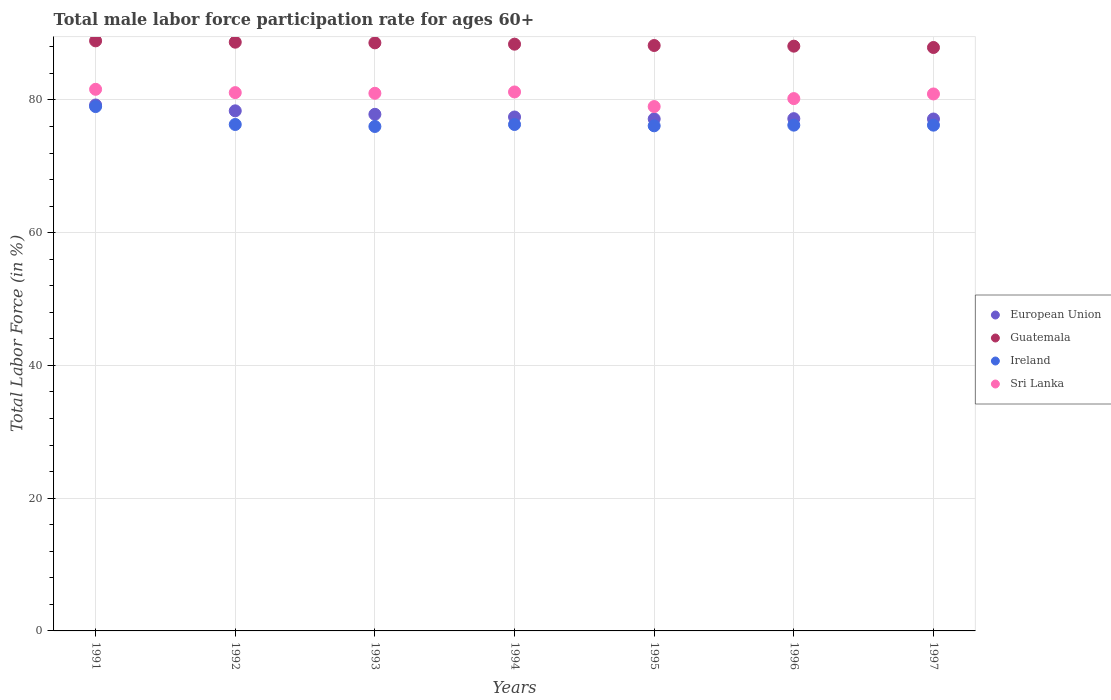How many different coloured dotlines are there?
Provide a short and direct response. 4. Is the number of dotlines equal to the number of legend labels?
Offer a terse response. Yes. What is the male labor force participation rate in European Union in 1997?
Provide a succinct answer. 77.12. Across all years, what is the maximum male labor force participation rate in Sri Lanka?
Provide a succinct answer. 81.6. Across all years, what is the minimum male labor force participation rate in European Union?
Make the answer very short. 77.12. In which year was the male labor force participation rate in Guatemala maximum?
Your answer should be very brief. 1991. What is the total male labor force participation rate in Guatemala in the graph?
Make the answer very short. 618.8. What is the difference between the male labor force participation rate in Sri Lanka in 1993 and that in 1996?
Provide a succinct answer. 0.8. What is the difference between the male labor force participation rate in Guatemala in 1994 and the male labor force participation rate in Sri Lanka in 1996?
Give a very brief answer. 8.2. What is the average male labor force participation rate in Ireland per year?
Provide a succinct answer. 76.59. In the year 1996, what is the difference between the male labor force participation rate in European Union and male labor force participation rate in Guatemala?
Your answer should be very brief. -10.92. What is the ratio of the male labor force participation rate in Guatemala in 1994 to that in 1996?
Your response must be concise. 1. Is the male labor force participation rate in Ireland in 1994 less than that in 1996?
Give a very brief answer. No. What is the difference between the highest and the second highest male labor force participation rate in Guatemala?
Offer a very short reply. 0.2. What is the difference between the highest and the lowest male labor force participation rate in Sri Lanka?
Give a very brief answer. 2.6. In how many years, is the male labor force participation rate in European Union greater than the average male labor force participation rate in European Union taken over all years?
Provide a succinct answer. 3. Is it the case that in every year, the sum of the male labor force participation rate in Sri Lanka and male labor force participation rate in Guatemala  is greater than the sum of male labor force participation rate in European Union and male labor force participation rate in Ireland?
Provide a short and direct response. No. Is it the case that in every year, the sum of the male labor force participation rate in European Union and male labor force participation rate in Sri Lanka  is greater than the male labor force participation rate in Guatemala?
Ensure brevity in your answer.  Yes. Is the male labor force participation rate in Ireland strictly less than the male labor force participation rate in Sri Lanka over the years?
Provide a succinct answer. Yes. How many dotlines are there?
Provide a short and direct response. 4. What is the difference between two consecutive major ticks on the Y-axis?
Provide a succinct answer. 20. Does the graph contain any zero values?
Make the answer very short. No. How are the legend labels stacked?
Offer a very short reply. Vertical. What is the title of the graph?
Your answer should be compact. Total male labor force participation rate for ages 60+. What is the label or title of the Y-axis?
Keep it short and to the point. Total Labor Force (in %). What is the Total Labor Force (in %) of European Union in 1991?
Your response must be concise. 79.24. What is the Total Labor Force (in %) of Guatemala in 1991?
Give a very brief answer. 88.9. What is the Total Labor Force (in %) in Ireland in 1991?
Ensure brevity in your answer.  79. What is the Total Labor Force (in %) in Sri Lanka in 1991?
Give a very brief answer. 81.6. What is the Total Labor Force (in %) of European Union in 1992?
Offer a very short reply. 78.36. What is the Total Labor Force (in %) in Guatemala in 1992?
Offer a terse response. 88.7. What is the Total Labor Force (in %) in Ireland in 1992?
Offer a very short reply. 76.3. What is the Total Labor Force (in %) in Sri Lanka in 1992?
Ensure brevity in your answer.  81.1. What is the Total Labor Force (in %) in European Union in 1993?
Provide a short and direct response. 77.83. What is the Total Labor Force (in %) of Guatemala in 1993?
Offer a very short reply. 88.6. What is the Total Labor Force (in %) in Sri Lanka in 1993?
Offer a very short reply. 81. What is the Total Labor Force (in %) in European Union in 1994?
Ensure brevity in your answer.  77.43. What is the Total Labor Force (in %) in Guatemala in 1994?
Your answer should be compact. 88.4. What is the Total Labor Force (in %) of Ireland in 1994?
Offer a terse response. 76.3. What is the Total Labor Force (in %) in Sri Lanka in 1994?
Ensure brevity in your answer.  81.2. What is the Total Labor Force (in %) of European Union in 1995?
Make the answer very short. 77.14. What is the Total Labor Force (in %) of Guatemala in 1995?
Your response must be concise. 88.2. What is the Total Labor Force (in %) in Ireland in 1995?
Ensure brevity in your answer.  76.1. What is the Total Labor Force (in %) of Sri Lanka in 1995?
Offer a terse response. 79. What is the Total Labor Force (in %) of European Union in 1996?
Keep it short and to the point. 77.18. What is the Total Labor Force (in %) of Guatemala in 1996?
Your response must be concise. 88.1. What is the Total Labor Force (in %) in Ireland in 1996?
Keep it short and to the point. 76.2. What is the Total Labor Force (in %) of Sri Lanka in 1996?
Keep it short and to the point. 80.2. What is the Total Labor Force (in %) in European Union in 1997?
Keep it short and to the point. 77.12. What is the Total Labor Force (in %) in Guatemala in 1997?
Ensure brevity in your answer.  87.9. What is the Total Labor Force (in %) in Ireland in 1997?
Keep it short and to the point. 76.2. What is the Total Labor Force (in %) in Sri Lanka in 1997?
Keep it short and to the point. 80.9. Across all years, what is the maximum Total Labor Force (in %) in European Union?
Provide a short and direct response. 79.24. Across all years, what is the maximum Total Labor Force (in %) in Guatemala?
Offer a terse response. 88.9. Across all years, what is the maximum Total Labor Force (in %) in Ireland?
Provide a succinct answer. 79. Across all years, what is the maximum Total Labor Force (in %) in Sri Lanka?
Offer a very short reply. 81.6. Across all years, what is the minimum Total Labor Force (in %) of European Union?
Offer a terse response. 77.12. Across all years, what is the minimum Total Labor Force (in %) of Guatemala?
Give a very brief answer. 87.9. Across all years, what is the minimum Total Labor Force (in %) of Ireland?
Your response must be concise. 76. Across all years, what is the minimum Total Labor Force (in %) in Sri Lanka?
Keep it short and to the point. 79. What is the total Total Labor Force (in %) in European Union in the graph?
Provide a succinct answer. 544.29. What is the total Total Labor Force (in %) of Guatemala in the graph?
Make the answer very short. 618.8. What is the total Total Labor Force (in %) in Ireland in the graph?
Your response must be concise. 536.1. What is the total Total Labor Force (in %) in Sri Lanka in the graph?
Give a very brief answer. 565. What is the difference between the Total Labor Force (in %) in European Union in 1991 and that in 1992?
Give a very brief answer. 0.88. What is the difference between the Total Labor Force (in %) in Guatemala in 1991 and that in 1992?
Make the answer very short. 0.2. What is the difference between the Total Labor Force (in %) of Sri Lanka in 1991 and that in 1992?
Provide a short and direct response. 0.5. What is the difference between the Total Labor Force (in %) in European Union in 1991 and that in 1993?
Offer a terse response. 1.41. What is the difference between the Total Labor Force (in %) of Guatemala in 1991 and that in 1993?
Your answer should be compact. 0.3. What is the difference between the Total Labor Force (in %) in Ireland in 1991 and that in 1993?
Keep it short and to the point. 3. What is the difference between the Total Labor Force (in %) of European Union in 1991 and that in 1994?
Offer a terse response. 1.81. What is the difference between the Total Labor Force (in %) of Guatemala in 1991 and that in 1994?
Your response must be concise. 0.5. What is the difference between the Total Labor Force (in %) of Sri Lanka in 1991 and that in 1994?
Make the answer very short. 0.4. What is the difference between the Total Labor Force (in %) in European Union in 1991 and that in 1995?
Your answer should be very brief. 2.1. What is the difference between the Total Labor Force (in %) of Guatemala in 1991 and that in 1995?
Ensure brevity in your answer.  0.7. What is the difference between the Total Labor Force (in %) in European Union in 1991 and that in 1996?
Give a very brief answer. 2.06. What is the difference between the Total Labor Force (in %) of Ireland in 1991 and that in 1996?
Provide a short and direct response. 2.8. What is the difference between the Total Labor Force (in %) in Sri Lanka in 1991 and that in 1996?
Offer a terse response. 1.4. What is the difference between the Total Labor Force (in %) of European Union in 1991 and that in 1997?
Give a very brief answer. 2.11. What is the difference between the Total Labor Force (in %) in Ireland in 1991 and that in 1997?
Keep it short and to the point. 2.8. What is the difference between the Total Labor Force (in %) in Sri Lanka in 1991 and that in 1997?
Offer a very short reply. 0.7. What is the difference between the Total Labor Force (in %) in European Union in 1992 and that in 1993?
Give a very brief answer. 0.53. What is the difference between the Total Labor Force (in %) in European Union in 1992 and that in 1994?
Your response must be concise. 0.93. What is the difference between the Total Labor Force (in %) of Guatemala in 1992 and that in 1994?
Provide a short and direct response. 0.3. What is the difference between the Total Labor Force (in %) of Ireland in 1992 and that in 1994?
Give a very brief answer. 0. What is the difference between the Total Labor Force (in %) in European Union in 1992 and that in 1995?
Provide a succinct answer. 1.22. What is the difference between the Total Labor Force (in %) of Sri Lanka in 1992 and that in 1995?
Give a very brief answer. 2.1. What is the difference between the Total Labor Force (in %) of European Union in 1992 and that in 1996?
Provide a succinct answer. 1.18. What is the difference between the Total Labor Force (in %) in European Union in 1992 and that in 1997?
Your answer should be compact. 1.23. What is the difference between the Total Labor Force (in %) in European Union in 1993 and that in 1994?
Make the answer very short. 0.4. What is the difference between the Total Labor Force (in %) in Guatemala in 1993 and that in 1994?
Keep it short and to the point. 0.2. What is the difference between the Total Labor Force (in %) of Ireland in 1993 and that in 1994?
Your response must be concise. -0.3. What is the difference between the Total Labor Force (in %) in Sri Lanka in 1993 and that in 1994?
Keep it short and to the point. -0.2. What is the difference between the Total Labor Force (in %) of European Union in 1993 and that in 1995?
Your answer should be compact. 0.69. What is the difference between the Total Labor Force (in %) of Guatemala in 1993 and that in 1995?
Your answer should be compact. 0.4. What is the difference between the Total Labor Force (in %) in Sri Lanka in 1993 and that in 1995?
Provide a succinct answer. 2. What is the difference between the Total Labor Force (in %) in European Union in 1993 and that in 1996?
Give a very brief answer. 0.66. What is the difference between the Total Labor Force (in %) in Sri Lanka in 1993 and that in 1996?
Offer a terse response. 0.8. What is the difference between the Total Labor Force (in %) of European Union in 1993 and that in 1997?
Offer a terse response. 0.71. What is the difference between the Total Labor Force (in %) of European Union in 1994 and that in 1995?
Keep it short and to the point. 0.29. What is the difference between the Total Labor Force (in %) in Guatemala in 1994 and that in 1995?
Your answer should be very brief. 0.2. What is the difference between the Total Labor Force (in %) of Ireland in 1994 and that in 1995?
Your response must be concise. 0.2. What is the difference between the Total Labor Force (in %) of Sri Lanka in 1994 and that in 1995?
Offer a terse response. 2.2. What is the difference between the Total Labor Force (in %) of European Union in 1994 and that in 1996?
Your answer should be compact. 0.25. What is the difference between the Total Labor Force (in %) in Guatemala in 1994 and that in 1996?
Ensure brevity in your answer.  0.3. What is the difference between the Total Labor Force (in %) of Ireland in 1994 and that in 1996?
Make the answer very short. 0.1. What is the difference between the Total Labor Force (in %) in Sri Lanka in 1994 and that in 1996?
Your answer should be compact. 1. What is the difference between the Total Labor Force (in %) in European Union in 1994 and that in 1997?
Provide a short and direct response. 0.3. What is the difference between the Total Labor Force (in %) of Guatemala in 1994 and that in 1997?
Provide a short and direct response. 0.5. What is the difference between the Total Labor Force (in %) in European Union in 1995 and that in 1996?
Give a very brief answer. -0.04. What is the difference between the Total Labor Force (in %) of Guatemala in 1995 and that in 1996?
Keep it short and to the point. 0.1. What is the difference between the Total Labor Force (in %) of Ireland in 1995 and that in 1996?
Offer a terse response. -0.1. What is the difference between the Total Labor Force (in %) in European Union in 1995 and that in 1997?
Your answer should be compact. 0.01. What is the difference between the Total Labor Force (in %) of Guatemala in 1995 and that in 1997?
Your answer should be compact. 0.3. What is the difference between the Total Labor Force (in %) of Ireland in 1995 and that in 1997?
Your answer should be very brief. -0.1. What is the difference between the Total Labor Force (in %) in Sri Lanka in 1995 and that in 1997?
Ensure brevity in your answer.  -1.9. What is the difference between the Total Labor Force (in %) of European Union in 1996 and that in 1997?
Provide a succinct answer. 0.05. What is the difference between the Total Labor Force (in %) in European Union in 1991 and the Total Labor Force (in %) in Guatemala in 1992?
Make the answer very short. -9.46. What is the difference between the Total Labor Force (in %) of European Union in 1991 and the Total Labor Force (in %) of Ireland in 1992?
Ensure brevity in your answer.  2.94. What is the difference between the Total Labor Force (in %) in European Union in 1991 and the Total Labor Force (in %) in Sri Lanka in 1992?
Ensure brevity in your answer.  -1.86. What is the difference between the Total Labor Force (in %) of Ireland in 1991 and the Total Labor Force (in %) of Sri Lanka in 1992?
Offer a very short reply. -2.1. What is the difference between the Total Labor Force (in %) of European Union in 1991 and the Total Labor Force (in %) of Guatemala in 1993?
Offer a very short reply. -9.36. What is the difference between the Total Labor Force (in %) in European Union in 1991 and the Total Labor Force (in %) in Ireland in 1993?
Provide a succinct answer. 3.24. What is the difference between the Total Labor Force (in %) in European Union in 1991 and the Total Labor Force (in %) in Sri Lanka in 1993?
Provide a short and direct response. -1.76. What is the difference between the Total Labor Force (in %) of Ireland in 1991 and the Total Labor Force (in %) of Sri Lanka in 1993?
Offer a terse response. -2. What is the difference between the Total Labor Force (in %) in European Union in 1991 and the Total Labor Force (in %) in Guatemala in 1994?
Your response must be concise. -9.16. What is the difference between the Total Labor Force (in %) in European Union in 1991 and the Total Labor Force (in %) in Ireland in 1994?
Offer a very short reply. 2.94. What is the difference between the Total Labor Force (in %) of European Union in 1991 and the Total Labor Force (in %) of Sri Lanka in 1994?
Offer a terse response. -1.96. What is the difference between the Total Labor Force (in %) in Guatemala in 1991 and the Total Labor Force (in %) in Ireland in 1994?
Offer a terse response. 12.6. What is the difference between the Total Labor Force (in %) of Guatemala in 1991 and the Total Labor Force (in %) of Sri Lanka in 1994?
Your answer should be very brief. 7.7. What is the difference between the Total Labor Force (in %) in Ireland in 1991 and the Total Labor Force (in %) in Sri Lanka in 1994?
Give a very brief answer. -2.2. What is the difference between the Total Labor Force (in %) of European Union in 1991 and the Total Labor Force (in %) of Guatemala in 1995?
Your response must be concise. -8.96. What is the difference between the Total Labor Force (in %) in European Union in 1991 and the Total Labor Force (in %) in Ireland in 1995?
Offer a very short reply. 3.14. What is the difference between the Total Labor Force (in %) in European Union in 1991 and the Total Labor Force (in %) in Sri Lanka in 1995?
Ensure brevity in your answer.  0.24. What is the difference between the Total Labor Force (in %) in Guatemala in 1991 and the Total Labor Force (in %) in Sri Lanka in 1995?
Give a very brief answer. 9.9. What is the difference between the Total Labor Force (in %) in Ireland in 1991 and the Total Labor Force (in %) in Sri Lanka in 1995?
Offer a very short reply. 0. What is the difference between the Total Labor Force (in %) in European Union in 1991 and the Total Labor Force (in %) in Guatemala in 1996?
Ensure brevity in your answer.  -8.86. What is the difference between the Total Labor Force (in %) in European Union in 1991 and the Total Labor Force (in %) in Ireland in 1996?
Provide a short and direct response. 3.04. What is the difference between the Total Labor Force (in %) of European Union in 1991 and the Total Labor Force (in %) of Sri Lanka in 1996?
Offer a very short reply. -0.96. What is the difference between the Total Labor Force (in %) of Guatemala in 1991 and the Total Labor Force (in %) of Sri Lanka in 1996?
Your response must be concise. 8.7. What is the difference between the Total Labor Force (in %) in European Union in 1991 and the Total Labor Force (in %) in Guatemala in 1997?
Ensure brevity in your answer.  -8.66. What is the difference between the Total Labor Force (in %) of European Union in 1991 and the Total Labor Force (in %) of Ireland in 1997?
Your answer should be very brief. 3.04. What is the difference between the Total Labor Force (in %) in European Union in 1991 and the Total Labor Force (in %) in Sri Lanka in 1997?
Your answer should be very brief. -1.66. What is the difference between the Total Labor Force (in %) in European Union in 1992 and the Total Labor Force (in %) in Guatemala in 1993?
Offer a terse response. -10.24. What is the difference between the Total Labor Force (in %) in European Union in 1992 and the Total Labor Force (in %) in Ireland in 1993?
Provide a short and direct response. 2.36. What is the difference between the Total Labor Force (in %) in European Union in 1992 and the Total Labor Force (in %) in Sri Lanka in 1993?
Offer a terse response. -2.64. What is the difference between the Total Labor Force (in %) of Guatemala in 1992 and the Total Labor Force (in %) of Sri Lanka in 1993?
Offer a very short reply. 7.7. What is the difference between the Total Labor Force (in %) in Ireland in 1992 and the Total Labor Force (in %) in Sri Lanka in 1993?
Make the answer very short. -4.7. What is the difference between the Total Labor Force (in %) of European Union in 1992 and the Total Labor Force (in %) of Guatemala in 1994?
Your response must be concise. -10.04. What is the difference between the Total Labor Force (in %) of European Union in 1992 and the Total Labor Force (in %) of Ireland in 1994?
Your answer should be compact. 2.06. What is the difference between the Total Labor Force (in %) in European Union in 1992 and the Total Labor Force (in %) in Sri Lanka in 1994?
Your response must be concise. -2.84. What is the difference between the Total Labor Force (in %) of Guatemala in 1992 and the Total Labor Force (in %) of Ireland in 1994?
Ensure brevity in your answer.  12.4. What is the difference between the Total Labor Force (in %) in European Union in 1992 and the Total Labor Force (in %) in Guatemala in 1995?
Keep it short and to the point. -9.84. What is the difference between the Total Labor Force (in %) in European Union in 1992 and the Total Labor Force (in %) in Ireland in 1995?
Provide a succinct answer. 2.26. What is the difference between the Total Labor Force (in %) of European Union in 1992 and the Total Labor Force (in %) of Sri Lanka in 1995?
Your answer should be compact. -0.64. What is the difference between the Total Labor Force (in %) of Guatemala in 1992 and the Total Labor Force (in %) of Sri Lanka in 1995?
Ensure brevity in your answer.  9.7. What is the difference between the Total Labor Force (in %) of Ireland in 1992 and the Total Labor Force (in %) of Sri Lanka in 1995?
Give a very brief answer. -2.7. What is the difference between the Total Labor Force (in %) in European Union in 1992 and the Total Labor Force (in %) in Guatemala in 1996?
Offer a terse response. -9.74. What is the difference between the Total Labor Force (in %) of European Union in 1992 and the Total Labor Force (in %) of Ireland in 1996?
Provide a succinct answer. 2.16. What is the difference between the Total Labor Force (in %) of European Union in 1992 and the Total Labor Force (in %) of Sri Lanka in 1996?
Ensure brevity in your answer.  -1.84. What is the difference between the Total Labor Force (in %) in European Union in 1992 and the Total Labor Force (in %) in Guatemala in 1997?
Ensure brevity in your answer.  -9.54. What is the difference between the Total Labor Force (in %) in European Union in 1992 and the Total Labor Force (in %) in Ireland in 1997?
Offer a terse response. 2.16. What is the difference between the Total Labor Force (in %) of European Union in 1992 and the Total Labor Force (in %) of Sri Lanka in 1997?
Ensure brevity in your answer.  -2.54. What is the difference between the Total Labor Force (in %) of European Union in 1993 and the Total Labor Force (in %) of Guatemala in 1994?
Keep it short and to the point. -10.57. What is the difference between the Total Labor Force (in %) of European Union in 1993 and the Total Labor Force (in %) of Ireland in 1994?
Your response must be concise. 1.53. What is the difference between the Total Labor Force (in %) in European Union in 1993 and the Total Labor Force (in %) in Sri Lanka in 1994?
Keep it short and to the point. -3.37. What is the difference between the Total Labor Force (in %) in Guatemala in 1993 and the Total Labor Force (in %) in Ireland in 1994?
Provide a short and direct response. 12.3. What is the difference between the Total Labor Force (in %) in Ireland in 1993 and the Total Labor Force (in %) in Sri Lanka in 1994?
Offer a very short reply. -5.2. What is the difference between the Total Labor Force (in %) in European Union in 1993 and the Total Labor Force (in %) in Guatemala in 1995?
Your response must be concise. -10.37. What is the difference between the Total Labor Force (in %) of European Union in 1993 and the Total Labor Force (in %) of Ireland in 1995?
Provide a succinct answer. 1.73. What is the difference between the Total Labor Force (in %) in European Union in 1993 and the Total Labor Force (in %) in Sri Lanka in 1995?
Keep it short and to the point. -1.17. What is the difference between the Total Labor Force (in %) of European Union in 1993 and the Total Labor Force (in %) of Guatemala in 1996?
Give a very brief answer. -10.27. What is the difference between the Total Labor Force (in %) in European Union in 1993 and the Total Labor Force (in %) in Ireland in 1996?
Ensure brevity in your answer.  1.63. What is the difference between the Total Labor Force (in %) of European Union in 1993 and the Total Labor Force (in %) of Sri Lanka in 1996?
Provide a short and direct response. -2.37. What is the difference between the Total Labor Force (in %) in Ireland in 1993 and the Total Labor Force (in %) in Sri Lanka in 1996?
Provide a succinct answer. -4.2. What is the difference between the Total Labor Force (in %) in European Union in 1993 and the Total Labor Force (in %) in Guatemala in 1997?
Make the answer very short. -10.07. What is the difference between the Total Labor Force (in %) in European Union in 1993 and the Total Labor Force (in %) in Ireland in 1997?
Your answer should be compact. 1.63. What is the difference between the Total Labor Force (in %) of European Union in 1993 and the Total Labor Force (in %) of Sri Lanka in 1997?
Your answer should be very brief. -3.07. What is the difference between the Total Labor Force (in %) in Guatemala in 1993 and the Total Labor Force (in %) in Ireland in 1997?
Your response must be concise. 12.4. What is the difference between the Total Labor Force (in %) in Ireland in 1993 and the Total Labor Force (in %) in Sri Lanka in 1997?
Keep it short and to the point. -4.9. What is the difference between the Total Labor Force (in %) in European Union in 1994 and the Total Labor Force (in %) in Guatemala in 1995?
Your answer should be compact. -10.77. What is the difference between the Total Labor Force (in %) in European Union in 1994 and the Total Labor Force (in %) in Ireland in 1995?
Make the answer very short. 1.33. What is the difference between the Total Labor Force (in %) in European Union in 1994 and the Total Labor Force (in %) in Sri Lanka in 1995?
Your answer should be very brief. -1.57. What is the difference between the Total Labor Force (in %) in Guatemala in 1994 and the Total Labor Force (in %) in Ireland in 1995?
Offer a terse response. 12.3. What is the difference between the Total Labor Force (in %) in Ireland in 1994 and the Total Labor Force (in %) in Sri Lanka in 1995?
Your response must be concise. -2.7. What is the difference between the Total Labor Force (in %) in European Union in 1994 and the Total Labor Force (in %) in Guatemala in 1996?
Provide a short and direct response. -10.67. What is the difference between the Total Labor Force (in %) of European Union in 1994 and the Total Labor Force (in %) of Ireland in 1996?
Offer a very short reply. 1.23. What is the difference between the Total Labor Force (in %) in European Union in 1994 and the Total Labor Force (in %) in Sri Lanka in 1996?
Keep it short and to the point. -2.77. What is the difference between the Total Labor Force (in %) in Guatemala in 1994 and the Total Labor Force (in %) in Ireland in 1996?
Offer a terse response. 12.2. What is the difference between the Total Labor Force (in %) of Guatemala in 1994 and the Total Labor Force (in %) of Sri Lanka in 1996?
Make the answer very short. 8.2. What is the difference between the Total Labor Force (in %) in Ireland in 1994 and the Total Labor Force (in %) in Sri Lanka in 1996?
Offer a terse response. -3.9. What is the difference between the Total Labor Force (in %) in European Union in 1994 and the Total Labor Force (in %) in Guatemala in 1997?
Ensure brevity in your answer.  -10.47. What is the difference between the Total Labor Force (in %) in European Union in 1994 and the Total Labor Force (in %) in Ireland in 1997?
Keep it short and to the point. 1.23. What is the difference between the Total Labor Force (in %) of European Union in 1994 and the Total Labor Force (in %) of Sri Lanka in 1997?
Provide a short and direct response. -3.47. What is the difference between the Total Labor Force (in %) in Guatemala in 1994 and the Total Labor Force (in %) in Sri Lanka in 1997?
Provide a succinct answer. 7.5. What is the difference between the Total Labor Force (in %) of Ireland in 1994 and the Total Labor Force (in %) of Sri Lanka in 1997?
Give a very brief answer. -4.6. What is the difference between the Total Labor Force (in %) of European Union in 1995 and the Total Labor Force (in %) of Guatemala in 1996?
Make the answer very short. -10.96. What is the difference between the Total Labor Force (in %) in European Union in 1995 and the Total Labor Force (in %) in Ireland in 1996?
Offer a terse response. 0.94. What is the difference between the Total Labor Force (in %) of European Union in 1995 and the Total Labor Force (in %) of Sri Lanka in 1996?
Your answer should be compact. -3.06. What is the difference between the Total Labor Force (in %) in Guatemala in 1995 and the Total Labor Force (in %) in Sri Lanka in 1996?
Ensure brevity in your answer.  8. What is the difference between the Total Labor Force (in %) of European Union in 1995 and the Total Labor Force (in %) of Guatemala in 1997?
Offer a very short reply. -10.76. What is the difference between the Total Labor Force (in %) in European Union in 1995 and the Total Labor Force (in %) in Ireland in 1997?
Your answer should be very brief. 0.94. What is the difference between the Total Labor Force (in %) in European Union in 1995 and the Total Labor Force (in %) in Sri Lanka in 1997?
Offer a very short reply. -3.76. What is the difference between the Total Labor Force (in %) in Guatemala in 1995 and the Total Labor Force (in %) in Sri Lanka in 1997?
Give a very brief answer. 7.3. What is the difference between the Total Labor Force (in %) in Ireland in 1995 and the Total Labor Force (in %) in Sri Lanka in 1997?
Provide a short and direct response. -4.8. What is the difference between the Total Labor Force (in %) in European Union in 1996 and the Total Labor Force (in %) in Guatemala in 1997?
Keep it short and to the point. -10.72. What is the difference between the Total Labor Force (in %) in European Union in 1996 and the Total Labor Force (in %) in Ireland in 1997?
Make the answer very short. 0.98. What is the difference between the Total Labor Force (in %) in European Union in 1996 and the Total Labor Force (in %) in Sri Lanka in 1997?
Provide a succinct answer. -3.72. What is the difference between the Total Labor Force (in %) of Guatemala in 1996 and the Total Labor Force (in %) of Ireland in 1997?
Provide a short and direct response. 11.9. What is the difference between the Total Labor Force (in %) in Guatemala in 1996 and the Total Labor Force (in %) in Sri Lanka in 1997?
Provide a short and direct response. 7.2. What is the average Total Labor Force (in %) of European Union per year?
Your answer should be compact. 77.76. What is the average Total Labor Force (in %) in Guatemala per year?
Offer a terse response. 88.4. What is the average Total Labor Force (in %) of Ireland per year?
Your answer should be compact. 76.59. What is the average Total Labor Force (in %) of Sri Lanka per year?
Your answer should be very brief. 80.71. In the year 1991, what is the difference between the Total Labor Force (in %) in European Union and Total Labor Force (in %) in Guatemala?
Ensure brevity in your answer.  -9.66. In the year 1991, what is the difference between the Total Labor Force (in %) in European Union and Total Labor Force (in %) in Ireland?
Your answer should be very brief. 0.24. In the year 1991, what is the difference between the Total Labor Force (in %) of European Union and Total Labor Force (in %) of Sri Lanka?
Make the answer very short. -2.36. In the year 1991, what is the difference between the Total Labor Force (in %) of Guatemala and Total Labor Force (in %) of Ireland?
Make the answer very short. 9.9. In the year 1991, what is the difference between the Total Labor Force (in %) of Ireland and Total Labor Force (in %) of Sri Lanka?
Provide a succinct answer. -2.6. In the year 1992, what is the difference between the Total Labor Force (in %) of European Union and Total Labor Force (in %) of Guatemala?
Provide a short and direct response. -10.34. In the year 1992, what is the difference between the Total Labor Force (in %) of European Union and Total Labor Force (in %) of Ireland?
Keep it short and to the point. 2.06. In the year 1992, what is the difference between the Total Labor Force (in %) of European Union and Total Labor Force (in %) of Sri Lanka?
Keep it short and to the point. -2.74. In the year 1992, what is the difference between the Total Labor Force (in %) of Guatemala and Total Labor Force (in %) of Ireland?
Give a very brief answer. 12.4. In the year 1992, what is the difference between the Total Labor Force (in %) of Guatemala and Total Labor Force (in %) of Sri Lanka?
Offer a terse response. 7.6. In the year 1992, what is the difference between the Total Labor Force (in %) of Ireland and Total Labor Force (in %) of Sri Lanka?
Your answer should be very brief. -4.8. In the year 1993, what is the difference between the Total Labor Force (in %) of European Union and Total Labor Force (in %) of Guatemala?
Keep it short and to the point. -10.77. In the year 1993, what is the difference between the Total Labor Force (in %) in European Union and Total Labor Force (in %) in Ireland?
Your answer should be compact. 1.83. In the year 1993, what is the difference between the Total Labor Force (in %) of European Union and Total Labor Force (in %) of Sri Lanka?
Provide a succinct answer. -3.17. In the year 1993, what is the difference between the Total Labor Force (in %) in Guatemala and Total Labor Force (in %) in Ireland?
Provide a short and direct response. 12.6. In the year 1994, what is the difference between the Total Labor Force (in %) of European Union and Total Labor Force (in %) of Guatemala?
Offer a terse response. -10.97. In the year 1994, what is the difference between the Total Labor Force (in %) of European Union and Total Labor Force (in %) of Ireland?
Offer a very short reply. 1.13. In the year 1994, what is the difference between the Total Labor Force (in %) in European Union and Total Labor Force (in %) in Sri Lanka?
Give a very brief answer. -3.77. In the year 1995, what is the difference between the Total Labor Force (in %) of European Union and Total Labor Force (in %) of Guatemala?
Keep it short and to the point. -11.06. In the year 1995, what is the difference between the Total Labor Force (in %) of European Union and Total Labor Force (in %) of Ireland?
Ensure brevity in your answer.  1.04. In the year 1995, what is the difference between the Total Labor Force (in %) of European Union and Total Labor Force (in %) of Sri Lanka?
Your response must be concise. -1.86. In the year 1995, what is the difference between the Total Labor Force (in %) in Guatemala and Total Labor Force (in %) in Ireland?
Your response must be concise. 12.1. In the year 1996, what is the difference between the Total Labor Force (in %) in European Union and Total Labor Force (in %) in Guatemala?
Your answer should be compact. -10.92. In the year 1996, what is the difference between the Total Labor Force (in %) of European Union and Total Labor Force (in %) of Ireland?
Your answer should be compact. 0.98. In the year 1996, what is the difference between the Total Labor Force (in %) in European Union and Total Labor Force (in %) in Sri Lanka?
Provide a succinct answer. -3.02. In the year 1996, what is the difference between the Total Labor Force (in %) in Guatemala and Total Labor Force (in %) in Sri Lanka?
Provide a short and direct response. 7.9. In the year 1996, what is the difference between the Total Labor Force (in %) in Ireland and Total Labor Force (in %) in Sri Lanka?
Give a very brief answer. -4. In the year 1997, what is the difference between the Total Labor Force (in %) of European Union and Total Labor Force (in %) of Guatemala?
Provide a short and direct response. -10.78. In the year 1997, what is the difference between the Total Labor Force (in %) in European Union and Total Labor Force (in %) in Ireland?
Provide a short and direct response. 0.92. In the year 1997, what is the difference between the Total Labor Force (in %) in European Union and Total Labor Force (in %) in Sri Lanka?
Give a very brief answer. -3.78. What is the ratio of the Total Labor Force (in %) of European Union in 1991 to that in 1992?
Make the answer very short. 1.01. What is the ratio of the Total Labor Force (in %) of Guatemala in 1991 to that in 1992?
Ensure brevity in your answer.  1. What is the ratio of the Total Labor Force (in %) in Ireland in 1991 to that in 1992?
Keep it short and to the point. 1.04. What is the ratio of the Total Labor Force (in %) of European Union in 1991 to that in 1993?
Ensure brevity in your answer.  1.02. What is the ratio of the Total Labor Force (in %) of Ireland in 1991 to that in 1993?
Keep it short and to the point. 1.04. What is the ratio of the Total Labor Force (in %) of Sri Lanka in 1991 to that in 1993?
Provide a succinct answer. 1.01. What is the ratio of the Total Labor Force (in %) of European Union in 1991 to that in 1994?
Your answer should be very brief. 1.02. What is the ratio of the Total Labor Force (in %) in Ireland in 1991 to that in 1994?
Offer a terse response. 1.04. What is the ratio of the Total Labor Force (in %) of European Union in 1991 to that in 1995?
Offer a very short reply. 1.03. What is the ratio of the Total Labor Force (in %) of Guatemala in 1991 to that in 1995?
Your answer should be compact. 1.01. What is the ratio of the Total Labor Force (in %) in Ireland in 1991 to that in 1995?
Offer a very short reply. 1.04. What is the ratio of the Total Labor Force (in %) of Sri Lanka in 1991 to that in 1995?
Give a very brief answer. 1.03. What is the ratio of the Total Labor Force (in %) in European Union in 1991 to that in 1996?
Your response must be concise. 1.03. What is the ratio of the Total Labor Force (in %) of Guatemala in 1991 to that in 1996?
Make the answer very short. 1.01. What is the ratio of the Total Labor Force (in %) in Ireland in 1991 to that in 1996?
Offer a terse response. 1.04. What is the ratio of the Total Labor Force (in %) in Sri Lanka in 1991 to that in 1996?
Offer a terse response. 1.02. What is the ratio of the Total Labor Force (in %) in European Union in 1991 to that in 1997?
Provide a short and direct response. 1.03. What is the ratio of the Total Labor Force (in %) in Guatemala in 1991 to that in 1997?
Provide a short and direct response. 1.01. What is the ratio of the Total Labor Force (in %) in Ireland in 1991 to that in 1997?
Offer a terse response. 1.04. What is the ratio of the Total Labor Force (in %) in Sri Lanka in 1991 to that in 1997?
Make the answer very short. 1.01. What is the ratio of the Total Labor Force (in %) of European Union in 1992 to that in 1993?
Your answer should be very brief. 1.01. What is the ratio of the Total Labor Force (in %) of European Union in 1992 to that in 1994?
Your response must be concise. 1.01. What is the ratio of the Total Labor Force (in %) in Ireland in 1992 to that in 1994?
Give a very brief answer. 1. What is the ratio of the Total Labor Force (in %) of Sri Lanka in 1992 to that in 1994?
Give a very brief answer. 1. What is the ratio of the Total Labor Force (in %) in European Union in 1992 to that in 1995?
Your response must be concise. 1.02. What is the ratio of the Total Labor Force (in %) of Ireland in 1992 to that in 1995?
Give a very brief answer. 1. What is the ratio of the Total Labor Force (in %) of Sri Lanka in 1992 to that in 1995?
Your answer should be very brief. 1.03. What is the ratio of the Total Labor Force (in %) of European Union in 1992 to that in 1996?
Provide a short and direct response. 1.02. What is the ratio of the Total Labor Force (in %) of Guatemala in 1992 to that in 1996?
Your answer should be very brief. 1.01. What is the ratio of the Total Labor Force (in %) of Ireland in 1992 to that in 1996?
Offer a very short reply. 1. What is the ratio of the Total Labor Force (in %) in Sri Lanka in 1992 to that in 1996?
Ensure brevity in your answer.  1.01. What is the ratio of the Total Labor Force (in %) in Guatemala in 1992 to that in 1997?
Offer a terse response. 1.01. What is the ratio of the Total Labor Force (in %) of Sri Lanka in 1992 to that in 1997?
Provide a succinct answer. 1. What is the ratio of the Total Labor Force (in %) in European Union in 1993 to that in 1994?
Your answer should be compact. 1.01. What is the ratio of the Total Labor Force (in %) of Sri Lanka in 1993 to that in 1994?
Give a very brief answer. 1. What is the ratio of the Total Labor Force (in %) in European Union in 1993 to that in 1995?
Make the answer very short. 1.01. What is the ratio of the Total Labor Force (in %) in Ireland in 1993 to that in 1995?
Offer a terse response. 1. What is the ratio of the Total Labor Force (in %) in Sri Lanka in 1993 to that in 1995?
Your answer should be very brief. 1.03. What is the ratio of the Total Labor Force (in %) in European Union in 1993 to that in 1996?
Offer a very short reply. 1.01. What is the ratio of the Total Labor Force (in %) of Sri Lanka in 1993 to that in 1996?
Provide a short and direct response. 1.01. What is the ratio of the Total Labor Force (in %) in European Union in 1993 to that in 1997?
Provide a short and direct response. 1.01. What is the ratio of the Total Labor Force (in %) of Guatemala in 1993 to that in 1997?
Offer a very short reply. 1.01. What is the ratio of the Total Labor Force (in %) of Sri Lanka in 1994 to that in 1995?
Ensure brevity in your answer.  1.03. What is the ratio of the Total Labor Force (in %) in European Union in 1994 to that in 1996?
Provide a short and direct response. 1. What is the ratio of the Total Labor Force (in %) of Sri Lanka in 1994 to that in 1996?
Your answer should be compact. 1.01. What is the ratio of the Total Labor Force (in %) in European Union in 1994 to that in 1997?
Make the answer very short. 1. What is the ratio of the Total Labor Force (in %) of Sri Lanka in 1994 to that in 1997?
Your response must be concise. 1. What is the ratio of the Total Labor Force (in %) of Guatemala in 1995 to that in 1997?
Give a very brief answer. 1. What is the ratio of the Total Labor Force (in %) of Ireland in 1995 to that in 1997?
Your answer should be compact. 1. What is the ratio of the Total Labor Force (in %) in Sri Lanka in 1995 to that in 1997?
Your answer should be very brief. 0.98. What is the ratio of the Total Labor Force (in %) in European Union in 1996 to that in 1997?
Keep it short and to the point. 1. What is the ratio of the Total Labor Force (in %) of Guatemala in 1996 to that in 1997?
Your response must be concise. 1. What is the difference between the highest and the second highest Total Labor Force (in %) of European Union?
Provide a succinct answer. 0.88. What is the difference between the highest and the second highest Total Labor Force (in %) of Ireland?
Your answer should be very brief. 2.7. What is the difference between the highest and the lowest Total Labor Force (in %) in European Union?
Give a very brief answer. 2.11. What is the difference between the highest and the lowest Total Labor Force (in %) of Guatemala?
Ensure brevity in your answer.  1. What is the difference between the highest and the lowest Total Labor Force (in %) of Ireland?
Provide a short and direct response. 3. 